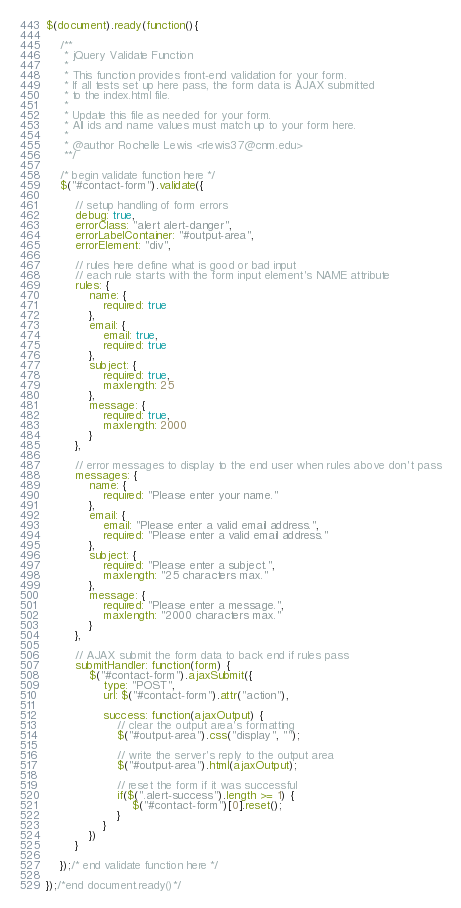<code> <loc_0><loc_0><loc_500><loc_500><_JavaScript_>$(document).ready(function(){

	/**
	 * jQuery Validate Function
	 *
	 * This function provides front-end validation for your form.
	 * If all tests set up here pass, the form data is AJAX submitted
	 * to the index.html file.
	 *
	 * Update this file as needed for your form.
	 * All ids and name values must match up to your form here.
	 *
	 * @author Rochelle Lewis <rlewis37@cnm.edu>
	 **/

	/* begin validate function here */
	$("#contact-form").validate({

		// setup handling of form errors
		debug: true,
		errorClass: "alert alert-danger",
		errorLabelContainer: "#output-area",
		errorElement: "div",

		// rules here define what is good or bad input
		// each rule starts with the form input element's NAME attribute
		rules: {
			name: {
				required: true
			},
			email: {
				email: true,
				required: true
			},
			subject: {
				required: true,
				maxlength: 25
			},
			message: {
				required: true,
				maxlength: 2000
			}
		},

		// error messages to display to the end user when rules above don't pass
		messages: {
			name: {
				required: "Please enter your name."
			},
			email: {
				email: "Please enter a valid email address.",
				required: "Please enter a valid email address."
			},
			subject: {
				required: "Please enter a subject.",
				maxlength: "25 characters max."
			},
			message: {
				required: "Please enter a message.",
				maxlength: "2000 characters max."
			}
		},

		// AJAX submit the form data to back end if rules pass
		submitHandler: function(form) {
			$("#contact-form").ajaxSubmit({
				type: "POST",
				url: $("#contact-form").attr("action"),

				success: function(ajaxOutput) {
					// clear the output area's formatting
					$("#output-area").css("display", "");

					// write the server's reply to the output area
					$("#output-area").html(ajaxOutput);

					// reset the form if it was successful
					if($(".alert-success").length >= 1) {
						$("#contact-form")[0].reset();
					}
				}
			})
		}

	});/* end validate function here */

});/*end document.ready()*/</code> 